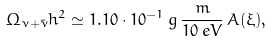Convert formula to latex. <formula><loc_0><loc_0><loc_500><loc_500>\Omega _ { \nu + \bar { \nu } } h ^ { 2 } \simeq 1 . 1 0 \cdot 1 0 ^ { - 1 } \, g \, \frac { m } { 1 0 \, e V } \, A ( \xi ) ,</formula> 